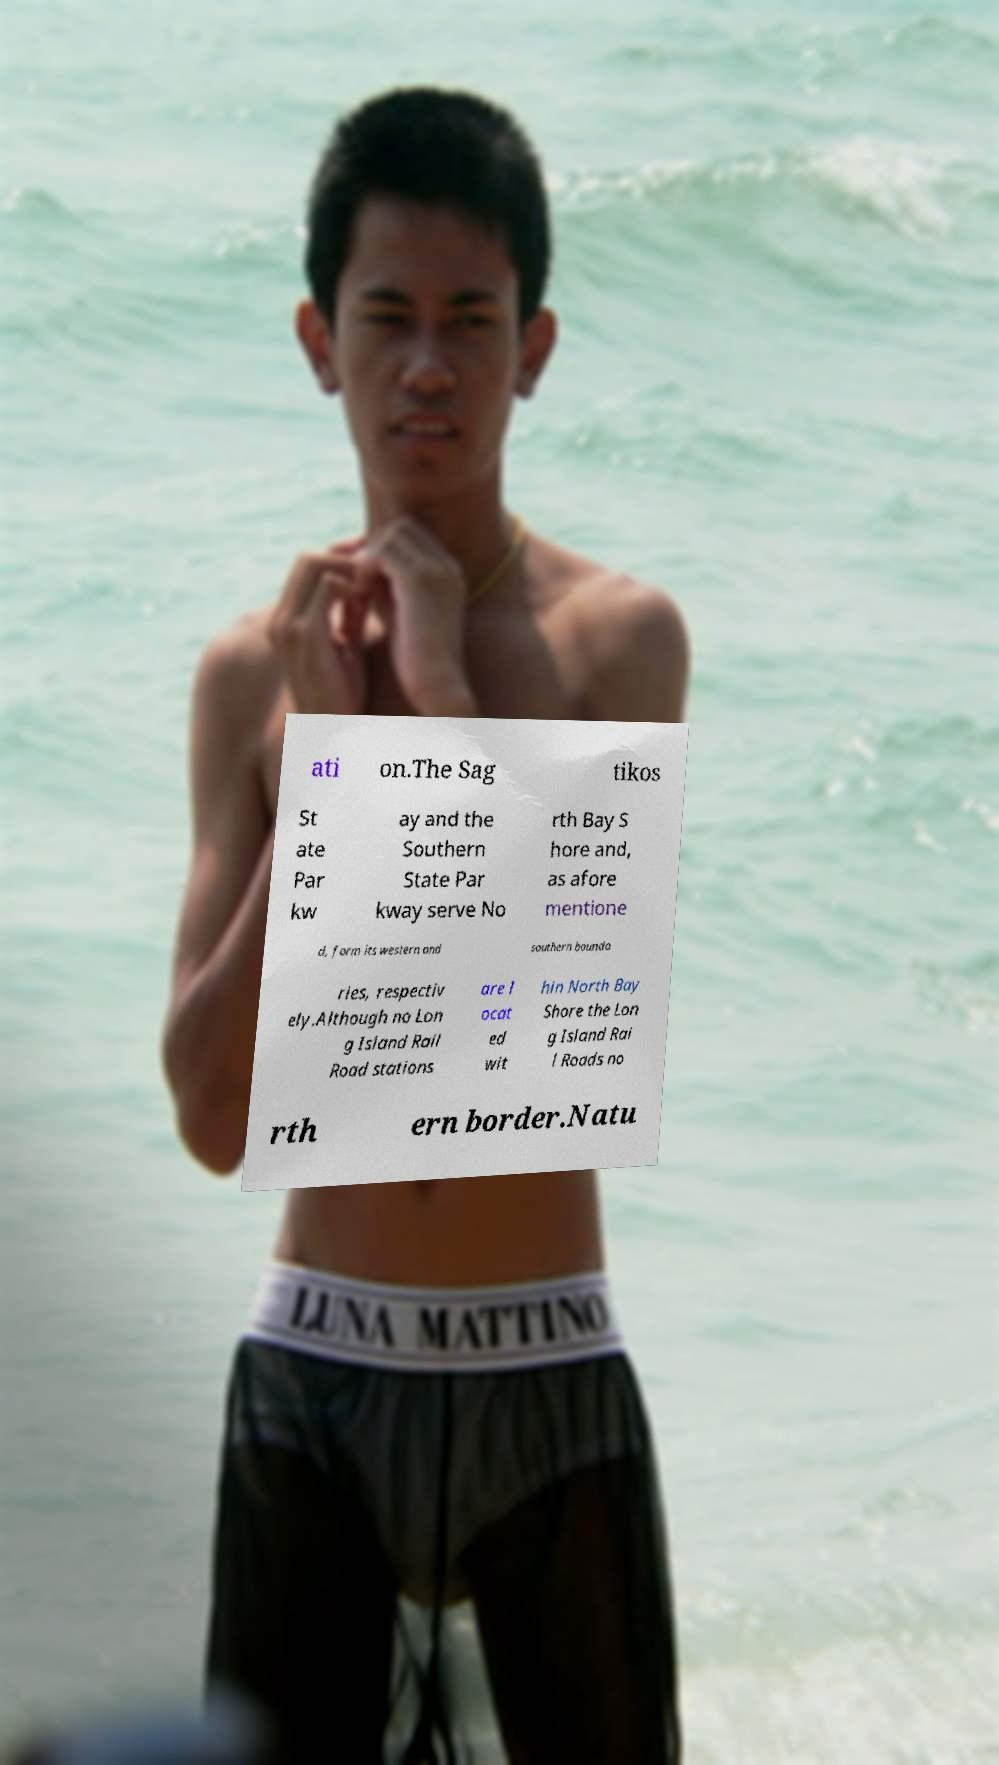There's text embedded in this image that I need extracted. Can you transcribe it verbatim? ati on.The Sag tikos St ate Par kw ay and the Southern State Par kway serve No rth Bay S hore and, as afore mentione d, form its western and southern bounda ries, respectiv ely.Although no Lon g Island Rail Road stations are l ocat ed wit hin North Bay Shore the Lon g Island Rai l Roads no rth ern border.Natu 